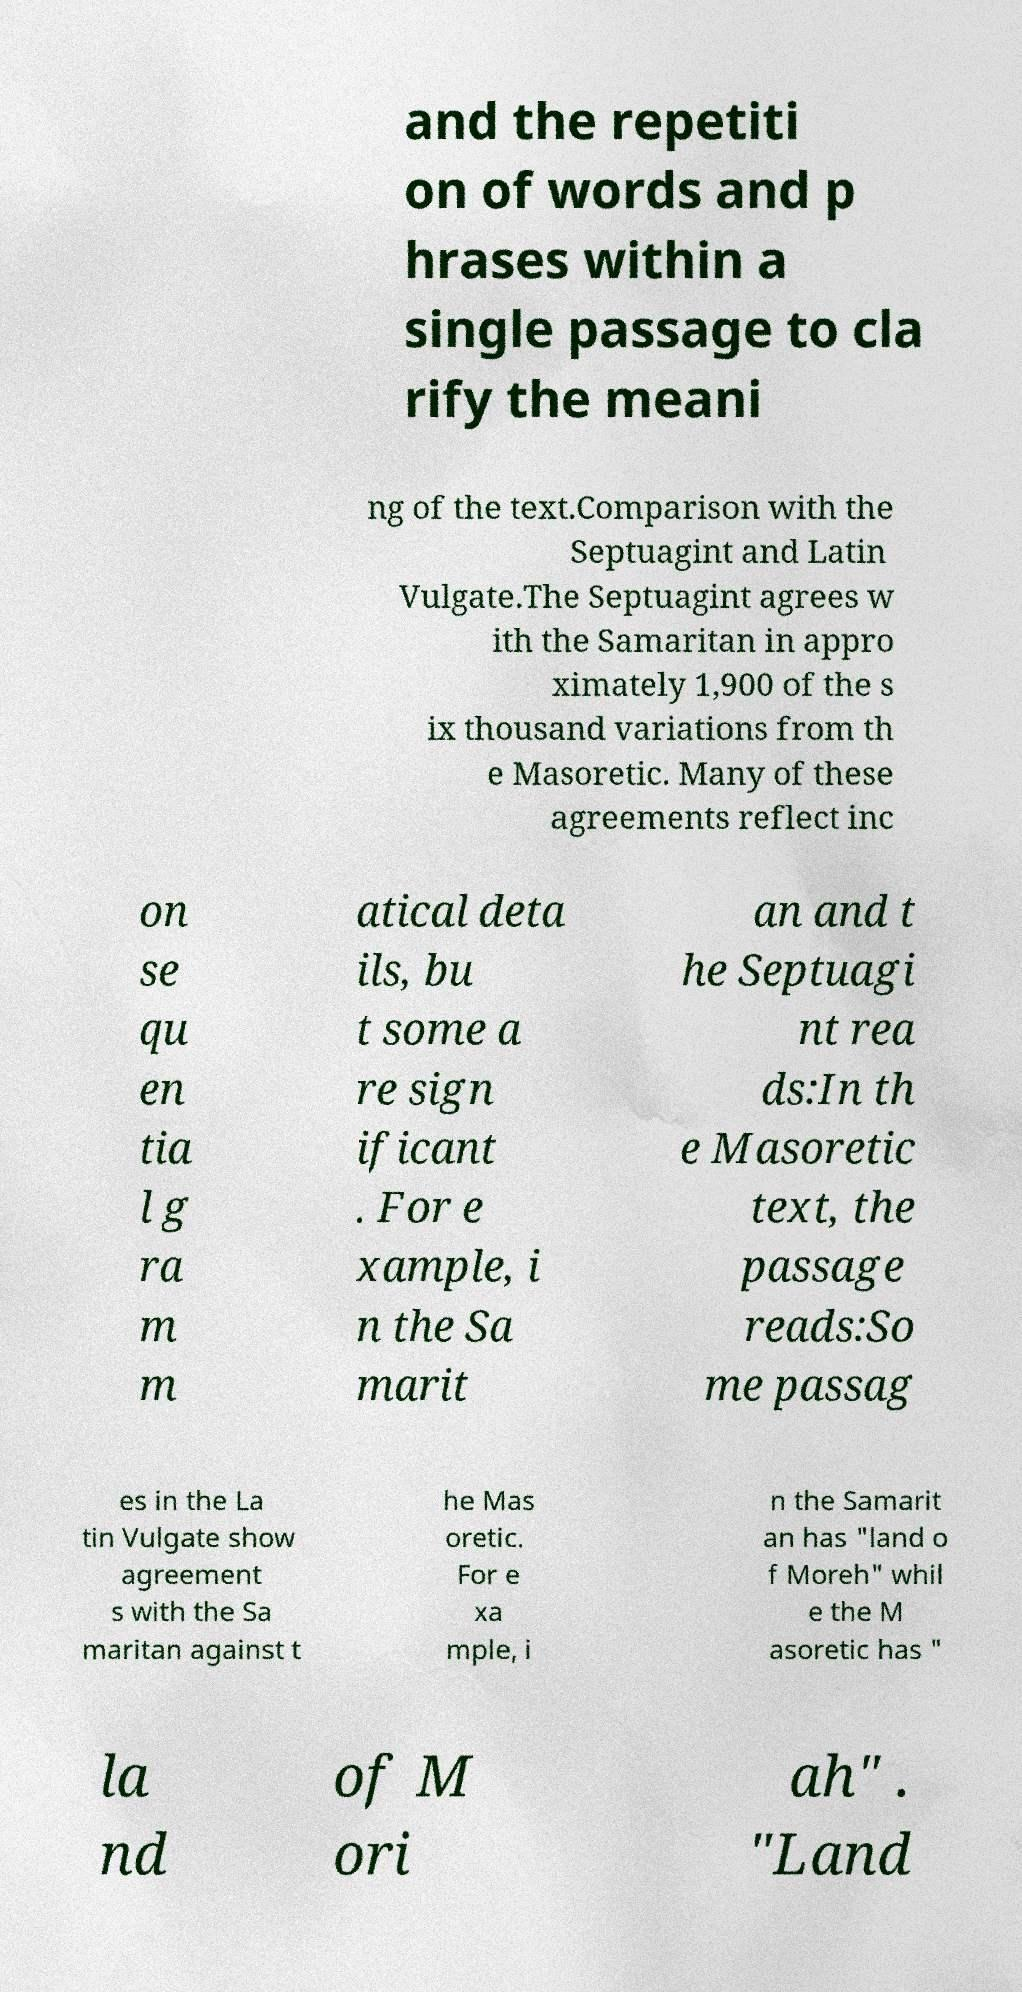Please read and relay the text visible in this image. What does it say? and the repetiti on of words and p hrases within a single passage to cla rify the meani ng of the text.Comparison with the Septuagint and Latin Vulgate.The Septuagint agrees w ith the Samaritan in appro ximately 1,900 of the s ix thousand variations from th e Masoretic. Many of these agreements reflect inc on se qu en tia l g ra m m atical deta ils, bu t some a re sign ificant . For e xample, i n the Sa marit an and t he Septuagi nt rea ds:In th e Masoretic text, the passage reads:So me passag es in the La tin Vulgate show agreement s with the Sa maritan against t he Mas oretic. For e xa mple, i n the Samarit an has "land o f Moreh" whil e the M asoretic has " la nd of M ori ah" . "Land 